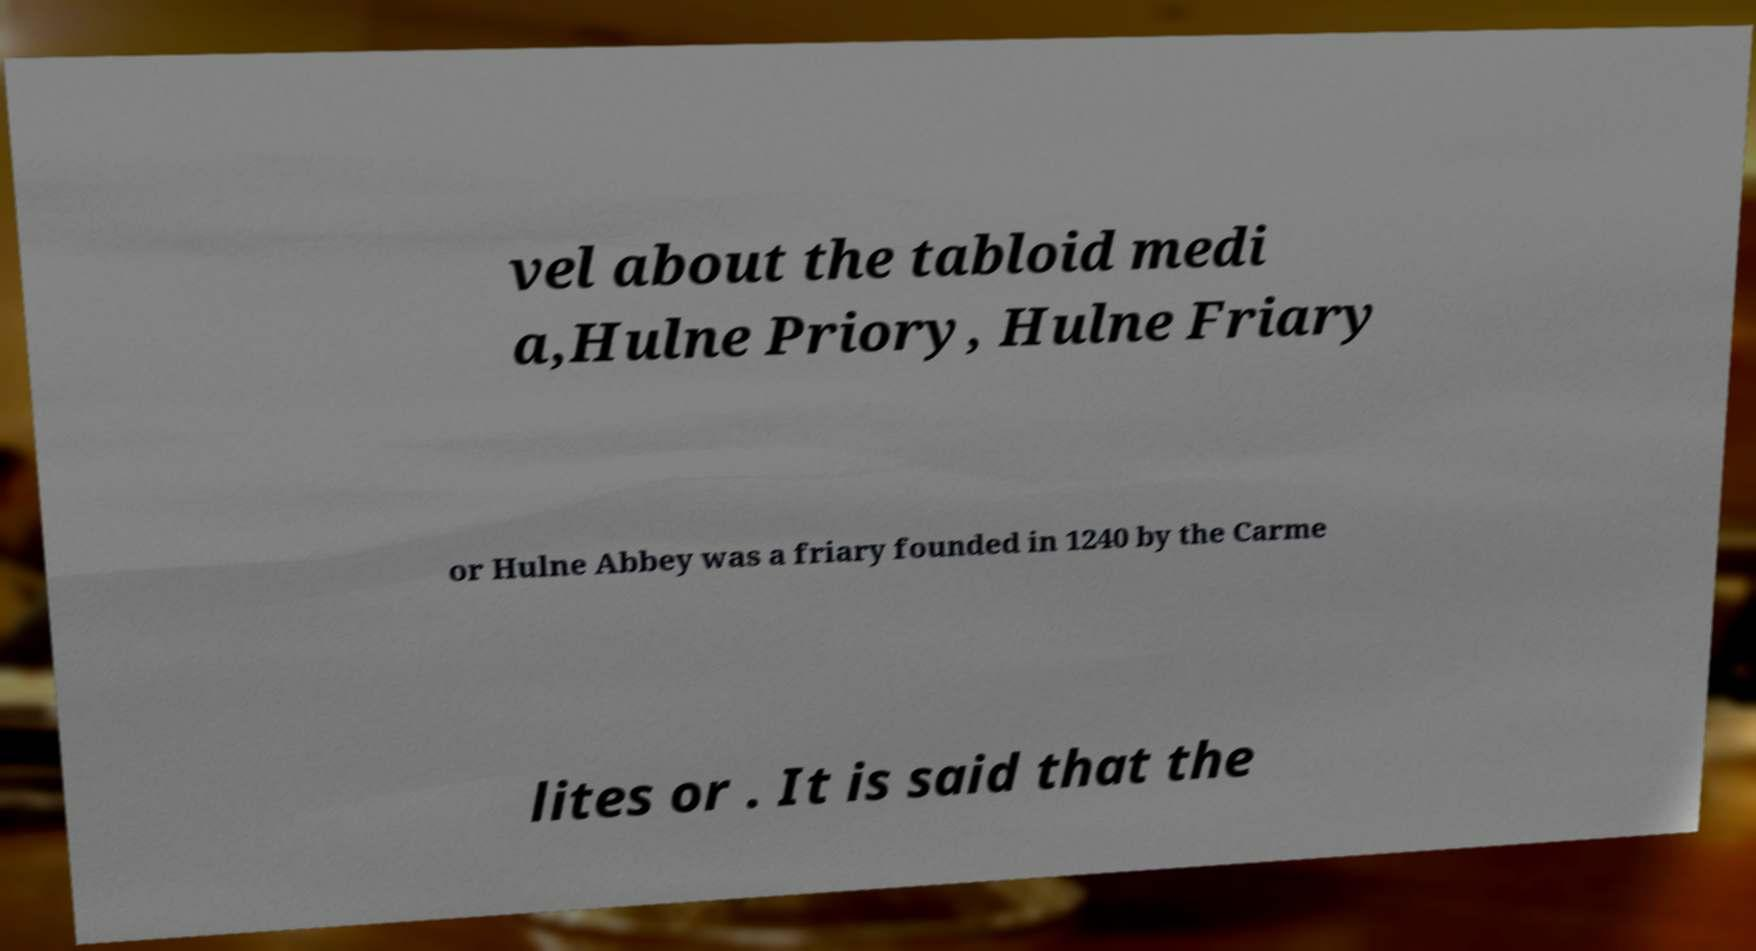I need the written content from this picture converted into text. Can you do that? vel about the tabloid medi a,Hulne Priory, Hulne Friary or Hulne Abbey was a friary founded in 1240 by the Carme lites or . It is said that the 